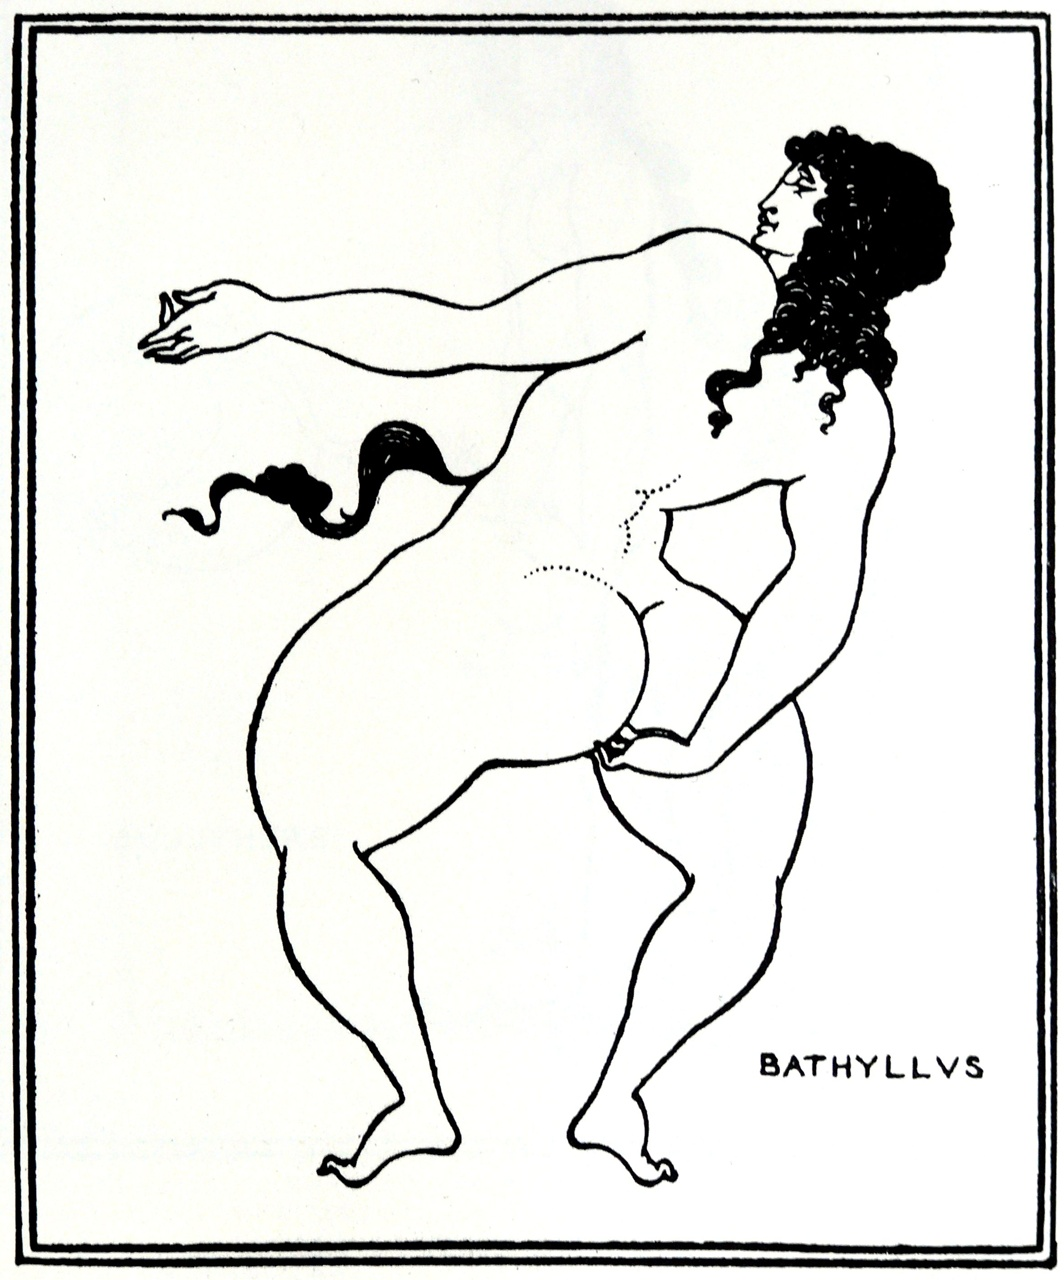What could be the historical context behind this image? The image’s stylistic elements suggest an inspiration from ancient Greek pottery, particularly the black-figure art prominent in Athens during the 6th century BC. This period celebrated athleticism, mythological narratives, and daily life in ceramic decorations. The figure ‘BATHYLLVS’ could reference an individual from ancient history or mythology, possibly a youth or lover associated with Greek tales. Artworks from this era often encapsulated virtues like strength, beauty, and heroism, immortalizing both gods and mortals in dynamic poses, as shown in this depiction. What might the small object in the right hand signify? The small object held by the figure could symbolize various elements depending on the context provided by its name, 'BATHYLLVS'. In Greek art, items held by figures often signify attributes or roles. It could be an offering, a musical instrument quite possibly a plectrum if ‘BATHYLLVS’ is linked to music, or even a tool denoting a particular profession or activity. Given the historical connotations, it could also be a laurel or myrtle branch, symbols of athletic victory or love respectively. 